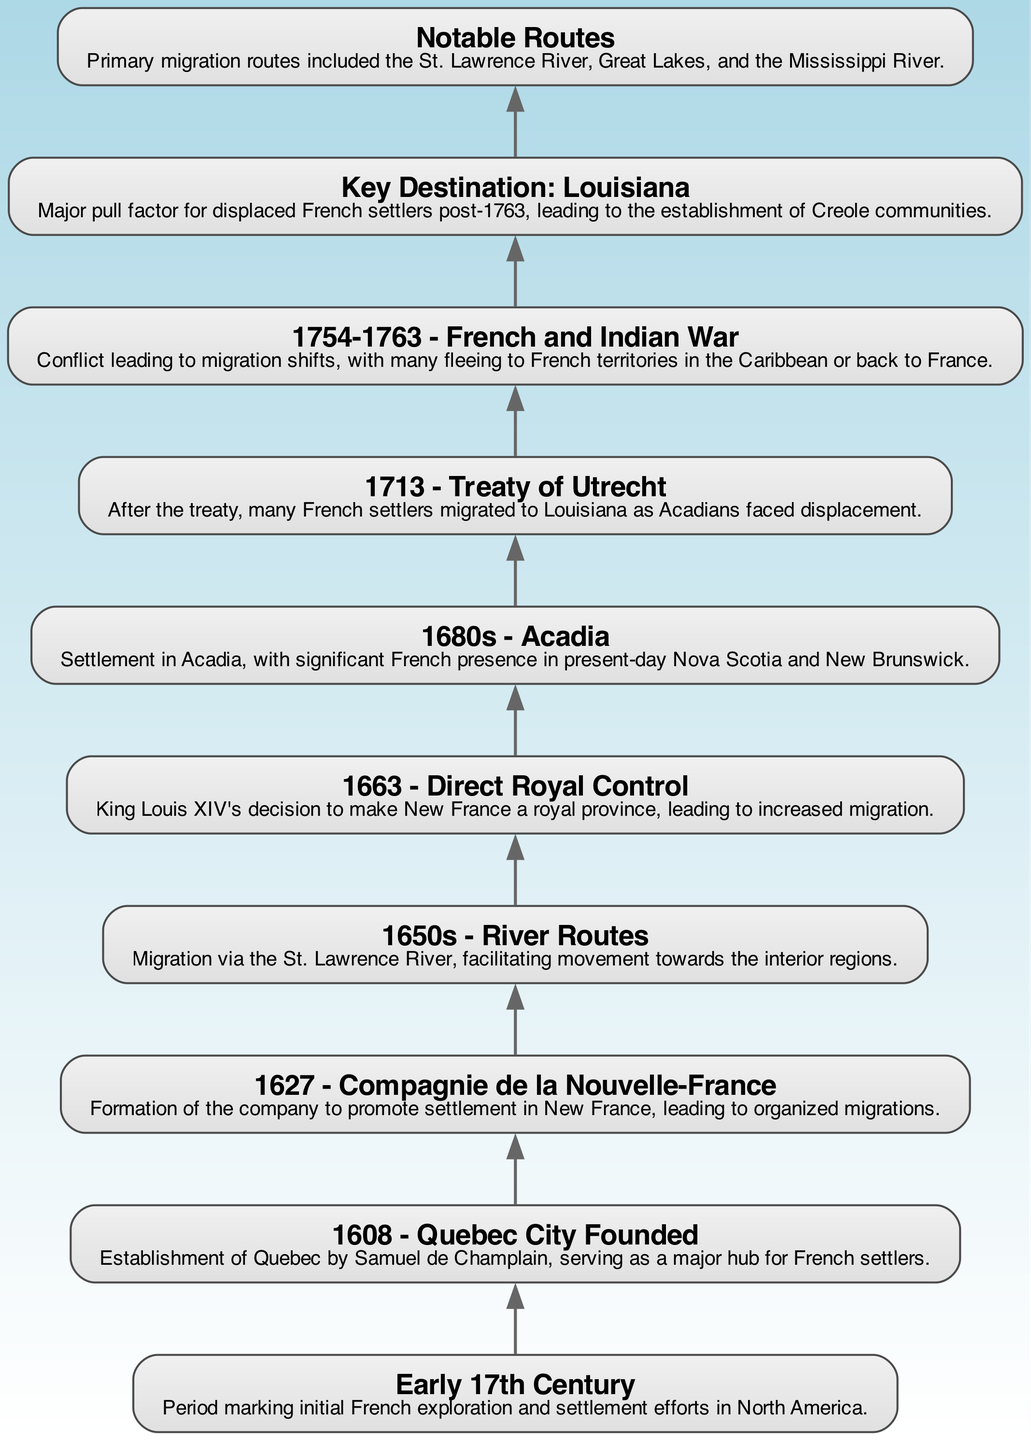What period marks initial French exploration efforts? The diagram indicates that the "Early 17th Century" is the period marking initial French exploration and settlement efforts in North America.
Answer: Early 17th Century Which significant city was founded in 1608? According to the diagram, the establishment of Quebec City in 1608 by Samuel de Champlain is noted as a major hub for French settlers.
Answer: Quebec City What year did the Compagnie de la Nouvelle-France form? The diagram specifies that the "Compagnie de la Nouvelle-France" was formed in the year 1627 to promote settlement in New France.
Answer: 1627 What major event occurred in 1713 impacting migration? The diagram shows that after the "Treaty of Utrecht" in 1713, many French settlers migrated to Louisiana as Acadians faced displacement.
Answer: Treaty of Utrecht What was a primary migration route for early French settlement? The diagram indicates that the "St. Lawrence River" was one of the primary migration routes facilitating movement towards the interior regions.
Answer: St. Lawrence River How did royal control in 1663 affect migration? The diagram states that King Louis XIV's decision to make New France a royal province in 1663 led to increased migration, indicating a stronger push from the crown for settlers to move to the region.
Answer: Increased migration What notable development happened in the 1680s? According to the diagram, during the 1680s, there was significant French settlement in Acadia, which included present-day Nova Scotia and New Brunswick.
Answer: Settlement in Acadia Which region attracted displaced French settlers post-1763? The diagram highlights that "Louisiana" became a major pull factor for displaced French settlers following the events of 1763.
Answer: Louisiana What conflict led to migration shifts from 1754-1763? The diagram identifies the "French and Indian War" as the conflict occurring from 1754 to 1763 that led to migration shifts for many French settlers.
Answer: French and Indian War 